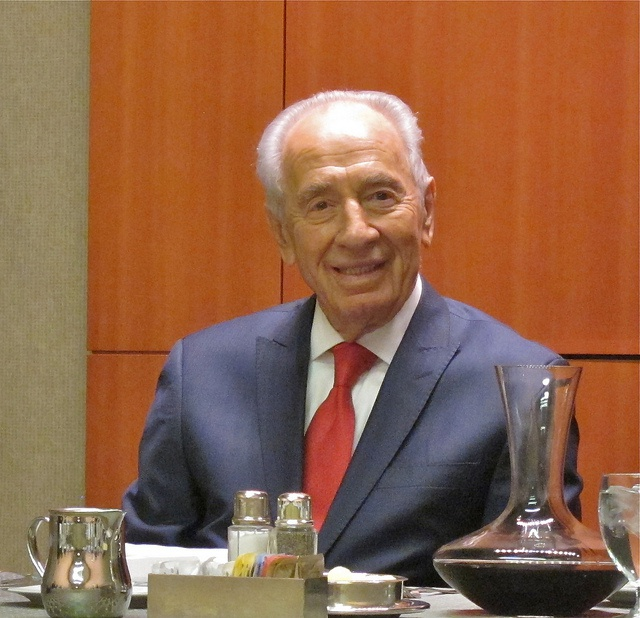Describe the objects in this image and their specific colors. I can see people in tan, gray, black, and brown tones, dining table in tan, olive, black, gray, and darkgray tones, cup in tan, gray, and darkgreen tones, tie in tan, brown, and maroon tones, and wine glass in tan, gray, and darkgray tones in this image. 